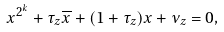<formula> <loc_0><loc_0><loc_500><loc_500>x ^ { 2 ^ { k } } + \tau _ { z } \overline { x } + ( 1 + \tau _ { z } ) x + \nu _ { z } = 0 ,</formula> 